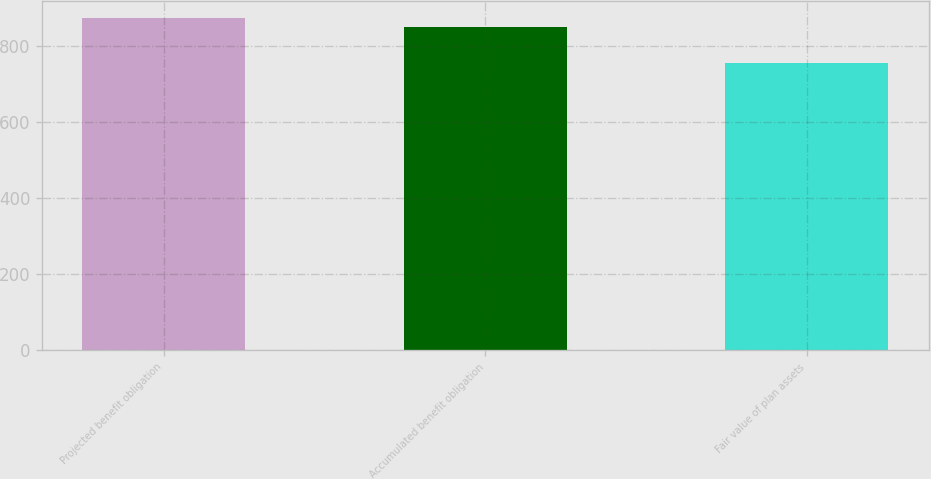Convert chart. <chart><loc_0><loc_0><loc_500><loc_500><bar_chart><fcel>Projected benefit obligation<fcel>Accumulated benefit obligation<fcel>Fair value of plan assets<nl><fcel>873<fcel>849<fcel>755<nl></chart> 